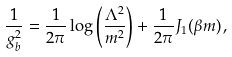Convert formula to latex. <formula><loc_0><loc_0><loc_500><loc_500>\frac { 1 } { g _ { b } ^ { 2 } } = \frac { 1 } { 2 \pi } \log \left ( \frac { \Lambda ^ { 2 } } { m ^ { 2 } } \right ) + \frac { 1 } { 2 \pi } J _ { 1 } ( \beta m ) \, ,</formula> 